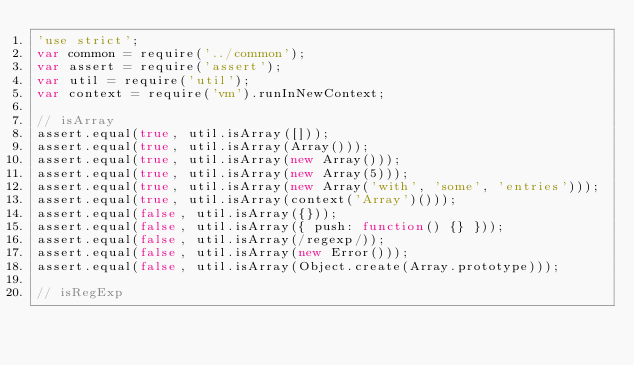<code> <loc_0><loc_0><loc_500><loc_500><_JavaScript_>'use strict';
var common = require('../common');
var assert = require('assert');
var util = require('util');
var context = require('vm').runInNewContext;

// isArray
assert.equal(true, util.isArray([]));
assert.equal(true, util.isArray(Array()));
assert.equal(true, util.isArray(new Array()));
assert.equal(true, util.isArray(new Array(5)));
assert.equal(true, util.isArray(new Array('with', 'some', 'entries')));
assert.equal(true, util.isArray(context('Array')()));
assert.equal(false, util.isArray({}));
assert.equal(false, util.isArray({ push: function() {} }));
assert.equal(false, util.isArray(/regexp/));
assert.equal(false, util.isArray(new Error()));
assert.equal(false, util.isArray(Object.create(Array.prototype)));

// isRegExp</code> 